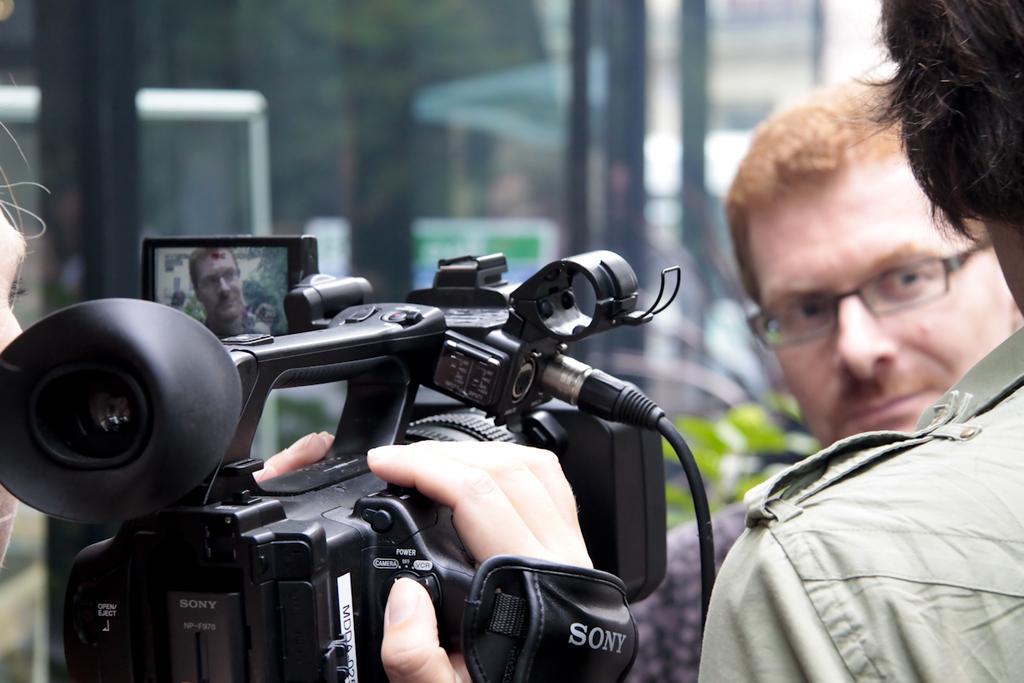Please provide a concise description of this image. In this picture I can see a person holding the camera. I can see two people on the right side. 